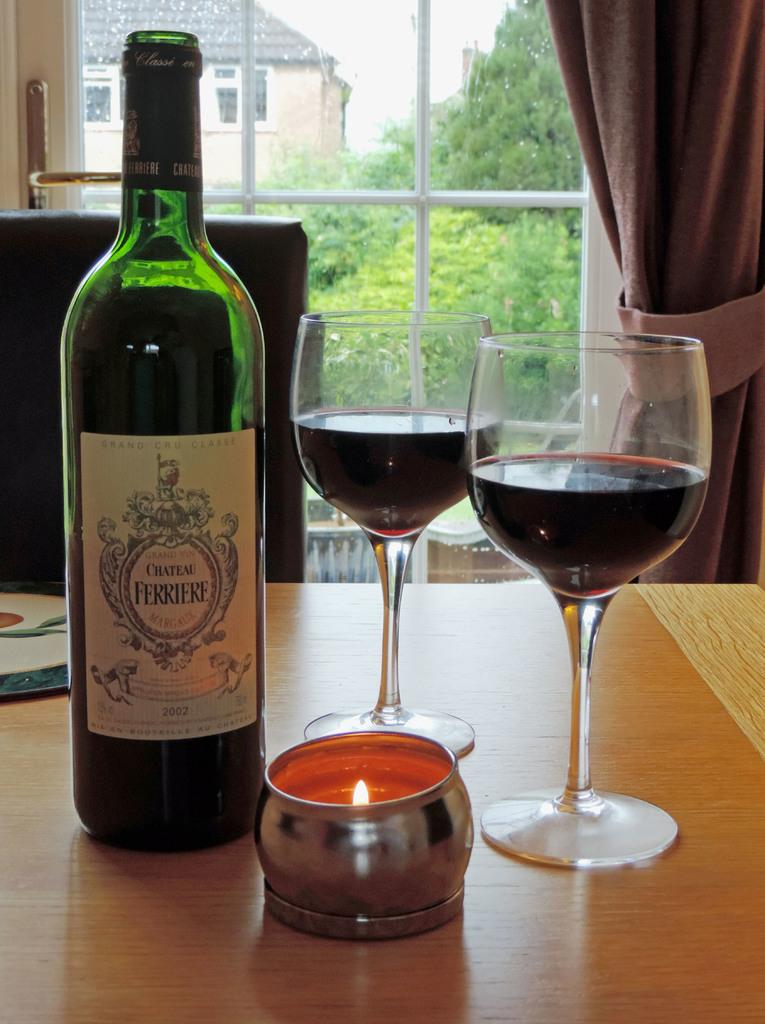<image>
Provide a brief description of the given image. A bottle of wine next to two glasses and a tea light, the wine is labelled Chateau Ferriere. 